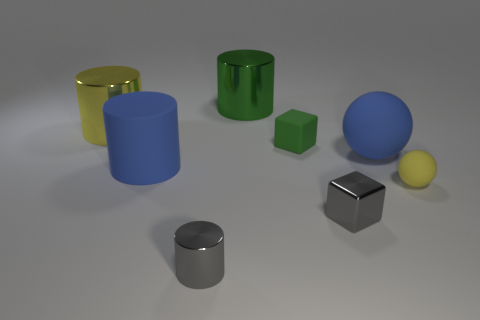What number of big things are spheres or green objects?
Give a very brief answer. 2. What color is the small metal thing that is the same shape as the small green rubber thing?
Offer a very short reply. Gray. Does the gray shiny cylinder have the same size as the gray cube?
Give a very brief answer. Yes. What number of objects are small green shiny cubes or things behind the gray shiny cylinder?
Offer a very short reply. 7. The large rubber thing that is to the left of the tiny block in front of the tiny ball is what color?
Your answer should be very brief. Blue. Is the color of the large matte object that is right of the small metallic cylinder the same as the matte cylinder?
Your answer should be compact. Yes. What is the tiny green thing in front of the large yellow cylinder made of?
Your answer should be compact. Rubber. What size is the green rubber object?
Your response must be concise. Small. Does the big blue object that is on the left side of the green metallic thing have the same material as the small yellow ball?
Your response must be concise. Yes. How many tiny green rubber cubes are there?
Give a very brief answer. 1. 